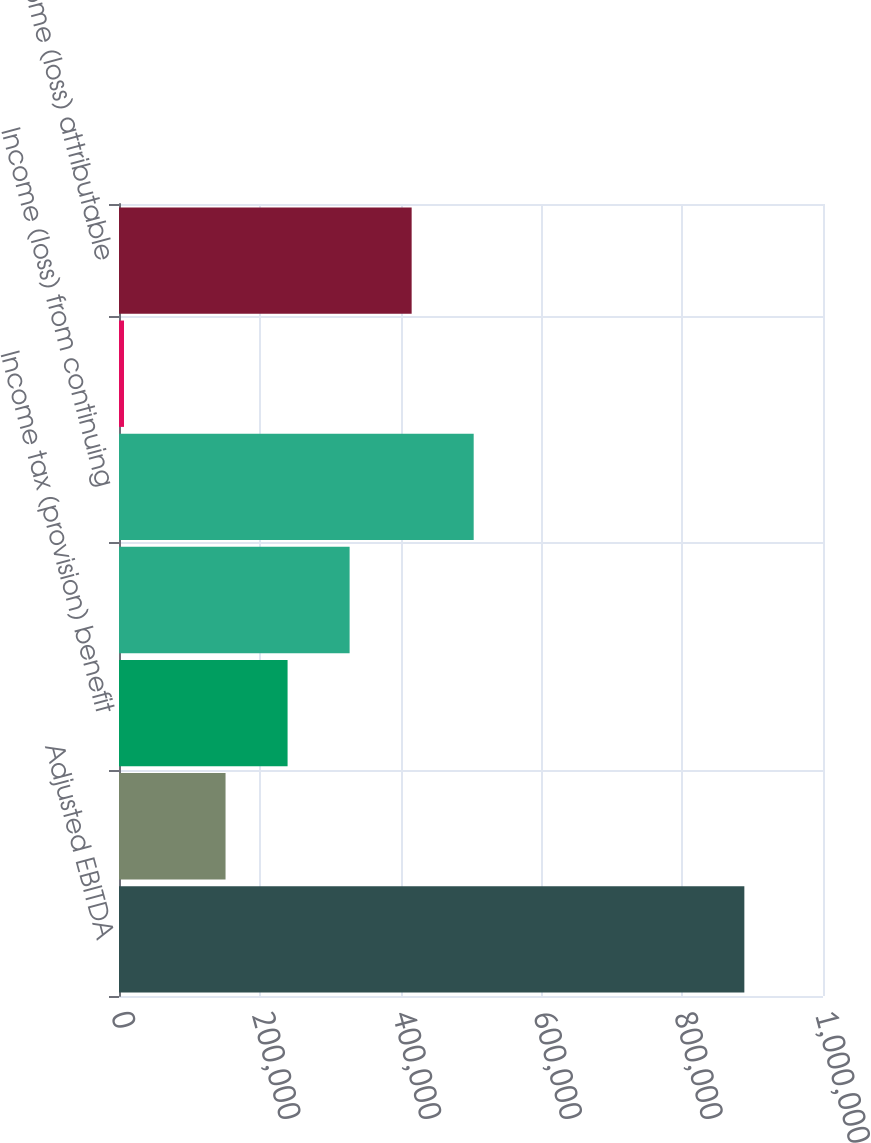Convert chart. <chart><loc_0><loc_0><loc_500><loc_500><bar_chart><fcel>Adjusted EBITDA<fcel>Interest expense net<fcel>Income tax (provision) benefit<fcel>Depreciation and amortization<fcel>Income (loss) from continuing<fcel>Plus Income (loss) from<fcel>Net income (loss) attributable<nl><fcel>888281<fcel>151343<fcel>239461<fcel>327580<fcel>503817<fcel>7097<fcel>415698<nl></chart> 